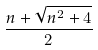<formula> <loc_0><loc_0><loc_500><loc_500>\frac { n + \sqrt { n ^ { 2 } + 4 } } { 2 }</formula> 